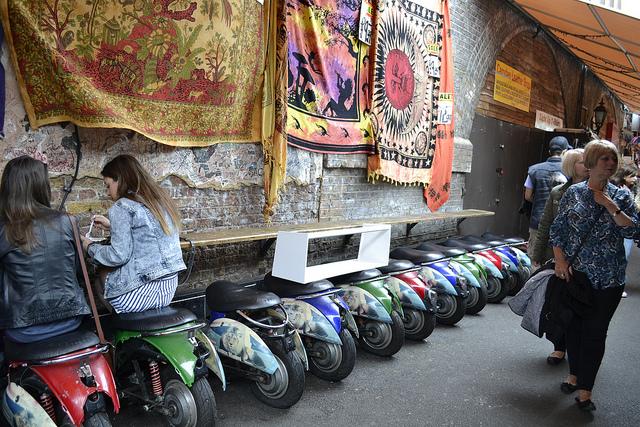Is anyone in this picture probably in high school?
Answer briefly. Yes. How many people are sitting down?
Write a very short answer. 2. What is hanging from the walls?
Concise answer only. Rugs. 